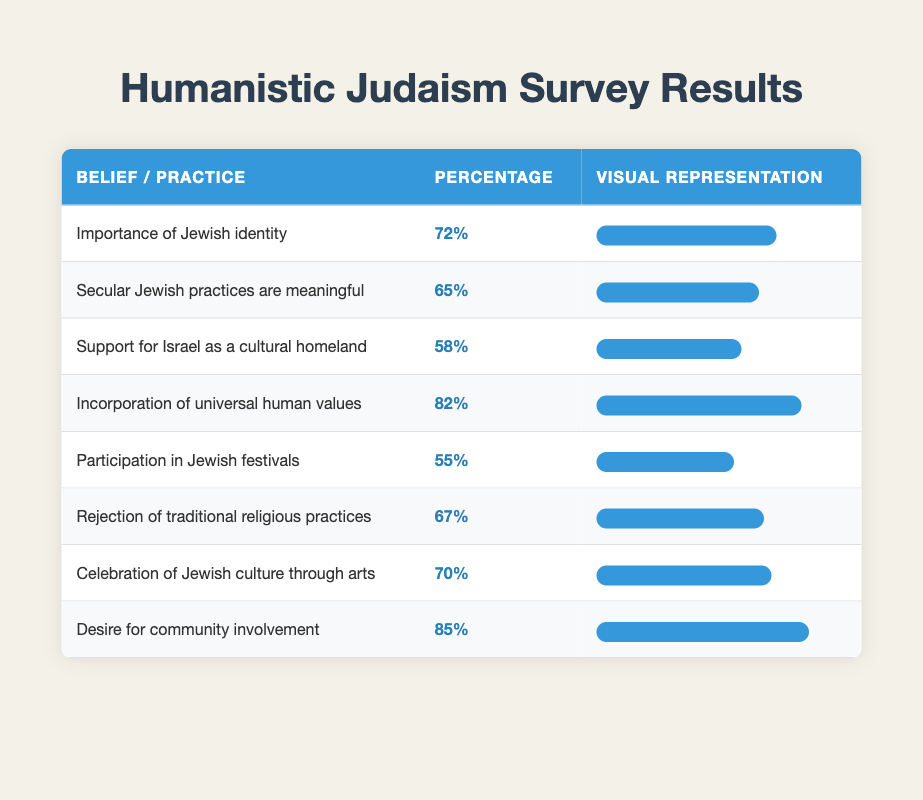What percentage of respondents find the importance of Jewish identity significant? The table lists the percentage for "Importance of Jewish identity," which is directly stated as 72%.
Answer: 72% How many respondents support the incorporation of universal human values? The total number of respondents is the same across all beliefs, which is 2000. The belief on incorporation of universal human values has a 82% support, so we can calculate 82% of 2000, which is (82/100) * 2000 = 1640 respondents.
Answer: 1640 Which belief has the highest percentage of support in the survey? By looking through the percentages, "Desire for community involvement" shows the highest percentage at 85%.
Answer: 85% What is the average percentage of support for the beliefs regarding cultural aspects (Support for Israel as a cultural homeland, Celebration of Jewish culture through arts, and Participation in Jewish festivals)? First, we extract the percentages: Israel (58%), Arts (70%), Festivals (55%). We then calculate the average: (58 + 70 + 55) / 3 = 183 / 3 = 61%.
Answer: 61% Is there a majority opinion that secular Jewish practices are meaningful? The percentage for this belief is 65%, which is greater than 50%, indicating a majority opinion.
Answer: Yes What percentage of respondents reject traditional religious practices? The table shows that the percentage for rejection of traditional religious practices is 67%.
Answer: 67% How does the percentage of respondents indicating a desire for community involvement compare with those who find secular Jewish practices meaningful? The desire for community involvement is at 85%, while secular Jewish practices meaningful is at 65%. The difference is 85% - 65% = 20%, indicating a higher support for community involvement.
Answer: 20% What percentage of participants in this survey do not believe in the importance of Jewish identity? Knowing that 72% support the importance of Jewish identity, we can find the opposite by subtracting this from 100%. Thus, 100% - 72% = 28% do not believe in its importance.
Answer: 28% Are more respondents in favor of participating in Jewish festivals than rejecting traditional religious practices? The percentage for participation in Jewish festivals is 55% and for rejection of traditional religious practices is 67%. Since 55% is less than 67%, the answer is no.
Answer: No 